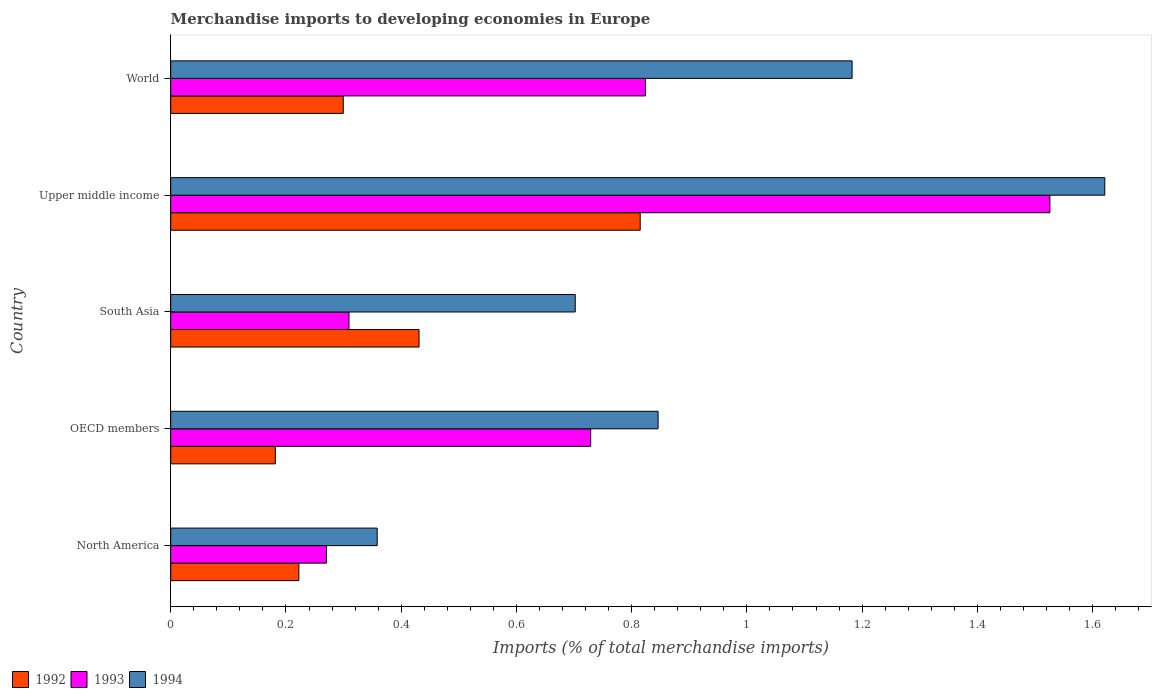How many different coloured bars are there?
Provide a short and direct response. 3. How many groups of bars are there?
Give a very brief answer. 5. Are the number of bars on each tick of the Y-axis equal?
Your answer should be compact. Yes. How many bars are there on the 5th tick from the top?
Give a very brief answer. 3. What is the label of the 1st group of bars from the top?
Offer a terse response. World. In how many cases, is the number of bars for a given country not equal to the number of legend labels?
Your answer should be compact. 0. What is the percentage total merchandise imports in 1994 in North America?
Keep it short and to the point. 0.36. Across all countries, what is the maximum percentage total merchandise imports in 1993?
Your response must be concise. 1.53. Across all countries, what is the minimum percentage total merchandise imports in 1992?
Keep it short and to the point. 0.18. In which country was the percentage total merchandise imports in 1993 maximum?
Provide a succinct answer. Upper middle income. In which country was the percentage total merchandise imports in 1994 minimum?
Provide a succinct answer. North America. What is the total percentage total merchandise imports in 1992 in the graph?
Your answer should be very brief. 1.95. What is the difference between the percentage total merchandise imports in 1994 in South Asia and that in Upper middle income?
Your answer should be compact. -0.92. What is the difference between the percentage total merchandise imports in 1994 in South Asia and the percentage total merchandise imports in 1993 in World?
Provide a short and direct response. -0.12. What is the average percentage total merchandise imports in 1992 per country?
Ensure brevity in your answer.  0.39. What is the difference between the percentage total merchandise imports in 1994 and percentage total merchandise imports in 1992 in Upper middle income?
Give a very brief answer. 0.81. What is the ratio of the percentage total merchandise imports in 1993 in OECD members to that in South Asia?
Offer a very short reply. 2.36. Is the percentage total merchandise imports in 1994 in North America less than that in World?
Offer a very short reply. Yes. What is the difference between the highest and the second highest percentage total merchandise imports in 1992?
Provide a short and direct response. 0.38. What is the difference between the highest and the lowest percentage total merchandise imports in 1993?
Your answer should be very brief. 1.26. In how many countries, is the percentage total merchandise imports in 1994 greater than the average percentage total merchandise imports in 1994 taken over all countries?
Your answer should be very brief. 2. Is the sum of the percentage total merchandise imports in 1993 in North America and OECD members greater than the maximum percentage total merchandise imports in 1994 across all countries?
Keep it short and to the point. No. What does the 1st bar from the top in South Asia represents?
Give a very brief answer. 1994. What does the 1st bar from the bottom in OECD members represents?
Provide a succinct answer. 1992. How many bars are there?
Provide a short and direct response. 15. How many countries are there in the graph?
Provide a succinct answer. 5. What is the difference between two consecutive major ticks on the X-axis?
Ensure brevity in your answer.  0.2. Does the graph contain any zero values?
Keep it short and to the point. No. Does the graph contain grids?
Your answer should be very brief. No. What is the title of the graph?
Provide a short and direct response. Merchandise imports to developing economies in Europe. Does "1968" appear as one of the legend labels in the graph?
Your answer should be very brief. No. What is the label or title of the X-axis?
Offer a very short reply. Imports (% of total merchandise imports). What is the label or title of the Y-axis?
Make the answer very short. Country. What is the Imports (% of total merchandise imports) in 1992 in North America?
Your response must be concise. 0.22. What is the Imports (% of total merchandise imports) in 1993 in North America?
Your response must be concise. 0.27. What is the Imports (% of total merchandise imports) in 1994 in North America?
Provide a short and direct response. 0.36. What is the Imports (% of total merchandise imports) in 1992 in OECD members?
Provide a succinct answer. 0.18. What is the Imports (% of total merchandise imports) in 1993 in OECD members?
Keep it short and to the point. 0.73. What is the Imports (% of total merchandise imports) of 1994 in OECD members?
Keep it short and to the point. 0.85. What is the Imports (% of total merchandise imports) in 1992 in South Asia?
Give a very brief answer. 0.43. What is the Imports (% of total merchandise imports) in 1993 in South Asia?
Make the answer very short. 0.31. What is the Imports (% of total merchandise imports) in 1994 in South Asia?
Keep it short and to the point. 0.7. What is the Imports (% of total merchandise imports) of 1992 in Upper middle income?
Your response must be concise. 0.81. What is the Imports (% of total merchandise imports) in 1993 in Upper middle income?
Your response must be concise. 1.53. What is the Imports (% of total merchandise imports) of 1994 in Upper middle income?
Make the answer very short. 1.62. What is the Imports (% of total merchandise imports) of 1992 in World?
Your response must be concise. 0.3. What is the Imports (% of total merchandise imports) in 1993 in World?
Your answer should be very brief. 0.82. What is the Imports (% of total merchandise imports) in 1994 in World?
Provide a succinct answer. 1.18. Across all countries, what is the maximum Imports (% of total merchandise imports) in 1992?
Make the answer very short. 0.81. Across all countries, what is the maximum Imports (% of total merchandise imports) in 1993?
Make the answer very short. 1.53. Across all countries, what is the maximum Imports (% of total merchandise imports) of 1994?
Your response must be concise. 1.62. Across all countries, what is the minimum Imports (% of total merchandise imports) of 1992?
Keep it short and to the point. 0.18. Across all countries, what is the minimum Imports (% of total merchandise imports) in 1993?
Your response must be concise. 0.27. Across all countries, what is the minimum Imports (% of total merchandise imports) in 1994?
Provide a succinct answer. 0.36. What is the total Imports (% of total merchandise imports) in 1992 in the graph?
Ensure brevity in your answer.  1.95. What is the total Imports (% of total merchandise imports) of 1993 in the graph?
Your answer should be compact. 3.66. What is the total Imports (% of total merchandise imports) in 1994 in the graph?
Your response must be concise. 4.71. What is the difference between the Imports (% of total merchandise imports) in 1992 in North America and that in OECD members?
Give a very brief answer. 0.04. What is the difference between the Imports (% of total merchandise imports) of 1993 in North America and that in OECD members?
Your answer should be compact. -0.46. What is the difference between the Imports (% of total merchandise imports) of 1994 in North America and that in OECD members?
Give a very brief answer. -0.49. What is the difference between the Imports (% of total merchandise imports) of 1992 in North America and that in South Asia?
Offer a very short reply. -0.21. What is the difference between the Imports (% of total merchandise imports) of 1993 in North America and that in South Asia?
Keep it short and to the point. -0.04. What is the difference between the Imports (% of total merchandise imports) in 1994 in North America and that in South Asia?
Provide a succinct answer. -0.34. What is the difference between the Imports (% of total merchandise imports) in 1992 in North America and that in Upper middle income?
Your answer should be compact. -0.59. What is the difference between the Imports (% of total merchandise imports) of 1993 in North America and that in Upper middle income?
Give a very brief answer. -1.26. What is the difference between the Imports (% of total merchandise imports) of 1994 in North America and that in Upper middle income?
Offer a terse response. -1.26. What is the difference between the Imports (% of total merchandise imports) of 1992 in North America and that in World?
Make the answer very short. -0.08. What is the difference between the Imports (% of total merchandise imports) of 1993 in North America and that in World?
Ensure brevity in your answer.  -0.55. What is the difference between the Imports (% of total merchandise imports) in 1994 in North America and that in World?
Offer a very short reply. -0.82. What is the difference between the Imports (% of total merchandise imports) in 1992 in OECD members and that in South Asia?
Ensure brevity in your answer.  -0.25. What is the difference between the Imports (% of total merchandise imports) of 1993 in OECD members and that in South Asia?
Offer a terse response. 0.42. What is the difference between the Imports (% of total merchandise imports) in 1994 in OECD members and that in South Asia?
Ensure brevity in your answer.  0.14. What is the difference between the Imports (% of total merchandise imports) in 1992 in OECD members and that in Upper middle income?
Ensure brevity in your answer.  -0.63. What is the difference between the Imports (% of total merchandise imports) of 1993 in OECD members and that in Upper middle income?
Offer a very short reply. -0.8. What is the difference between the Imports (% of total merchandise imports) of 1994 in OECD members and that in Upper middle income?
Offer a very short reply. -0.78. What is the difference between the Imports (% of total merchandise imports) in 1992 in OECD members and that in World?
Provide a short and direct response. -0.12. What is the difference between the Imports (% of total merchandise imports) of 1993 in OECD members and that in World?
Offer a terse response. -0.1. What is the difference between the Imports (% of total merchandise imports) in 1994 in OECD members and that in World?
Your answer should be compact. -0.34. What is the difference between the Imports (% of total merchandise imports) in 1992 in South Asia and that in Upper middle income?
Offer a terse response. -0.38. What is the difference between the Imports (% of total merchandise imports) in 1993 in South Asia and that in Upper middle income?
Make the answer very short. -1.22. What is the difference between the Imports (% of total merchandise imports) in 1994 in South Asia and that in Upper middle income?
Your answer should be very brief. -0.92. What is the difference between the Imports (% of total merchandise imports) of 1992 in South Asia and that in World?
Keep it short and to the point. 0.13. What is the difference between the Imports (% of total merchandise imports) in 1993 in South Asia and that in World?
Your answer should be compact. -0.51. What is the difference between the Imports (% of total merchandise imports) in 1994 in South Asia and that in World?
Offer a very short reply. -0.48. What is the difference between the Imports (% of total merchandise imports) in 1992 in Upper middle income and that in World?
Provide a short and direct response. 0.52. What is the difference between the Imports (% of total merchandise imports) in 1993 in Upper middle income and that in World?
Your answer should be compact. 0.7. What is the difference between the Imports (% of total merchandise imports) of 1994 in Upper middle income and that in World?
Your answer should be very brief. 0.44. What is the difference between the Imports (% of total merchandise imports) of 1992 in North America and the Imports (% of total merchandise imports) of 1993 in OECD members?
Your answer should be compact. -0.51. What is the difference between the Imports (% of total merchandise imports) in 1992 in North America and the Imports (% of total merchandise imports) in 1994 in OECD members?
Offer a terse response. -0.62. What is the difference between the Imports (% of total merchandise imports) of 1993 in North America and the Imports (% of total merchandise imports) of 1994 in OECD members?
Provide a short and direct response. -0.58. What is the difference between the Imports (% of total merchandise imports) of 1992 in North America and the Imports (% of total merchandise imports) of 1993 in South Asia?
Your answer should be very brief. -0.09. What is the difference between the Imports (% of total merchandise imports) of 1992 in North America and the Imports (% of total merchandise imports) of 1994 in South Asia?
Make the answer very short. -0.48. What is the difference between the Imports (% of total merchandise imports) in 1993 in North America and the Imports (% of total merchandise imports) in 1994 in South Asia?
Keep it short and to the point. -0.43. What is the difference between the Imports (% of total merchandise imports) of 1992 in North America and the Imports (% of total merchandise imports) of 1993 in Upper middle income?
Keep it short and to the point. -1.3. What is the difference between the Imports (% of total merchandise imports) in 1992 in North America and the Imports (% of total merchandise imports) in 1994 in Upper middle income?
Your answer should be very brief. -1.4. What is the difference between the Imports (% of total merchandise imports) of 1993 in North America and the Imports (% of total merchandise imports) of 1994 in Upper middle income?
Your answer should be very brief. -1.35. What is the difference between the Imports (% of total merchandise imports) in 1992 in North America and the Imports (% of total merchandise imports) in 1993 in World?
Keep it short and to the point. -0.6. What is the difference between the Imports (% of total merchandise imports) of 1992 in North America and the Imports (% of total merchandise imports) of 1994 in World?
Keep it short and to the point. -0.96. What is the difference between the Imports (% of total merchandise imports) in 1993 in North America and the Imports (% of total merchandise imports) in 1994 in World?
Keep it short and to the point. -0.91. What is the difference between the Imports (% of total merchandise imports) in 1992 in OECD members and the Imports (% of total merchandise imports) in 1993 in South Asia?
Keep it short and to the point. -0.13. What is the difference between the Imports (% of total merchandise imports) of 1992 in OECD members and the Imports (% of total merchandise imports) of 1994 in South Asia?
Ensure brevity in your answer.  -0.52. What is the difference between the Imports (% of total merchandise imports) in 1993 in OECD members and the Imports (% of total merchandise imports) in 1994 in South Asia?
Your answer should be very brief. 0.03. What is the difference between the Imports (% of total merchandise imports) in 1992 in OECD members and the Imports (% of total merchandise imports) in 1993 in Upper middle income?
Offer a very short reply. -1.34. What is the difference between the Imports (% of total merchandise imports) in 1992 in OECD members and the Imports (% of total merchandise imports) in 1994 in Upper middle income?
Make the answer very short. -1.44. What is the difference between the Imports (% of total merchandise imports) of 1993 in OECD members and the Imports (% of total merchandise imports) of 1994 in Upper middle income?
Offer a very short reply. -0.89. What is the difference between the Imports (% of total merchandise imports) in 1992 in OECD members and the Imports (% of total merchandise imports) in 1993 in World?
Give a very brief answer. -0.64. What is the difference between the Imports (% of total merchandise imports) in 1992 in OECD members and the Imports (% of total merchandise imports) in 1994 in World?
Your answer should be compact. -1. What is the difference between the Imports (% of total merchandise imports) of 1993 in OECD members and the Imports (% of total merchandise imports) of 1994 in World?
Offer a terse response. -0.45. What is the difference between the Imports (% of total merchandise imports) of 1992 in South Asia and the Imports (% of total merchandise imports) of 1993 in Upper middle income?
Ensure brevity in your answer.  -1.09. What is the difference between the Imports (% of total merchandise imports) of 1992 in South Asia and the Imports (% of total merchandise imports) of 1994 in Upper middle income?
Provide a succinct answer. -1.19. What is the difference between the Imports (% of total merchandise imports) in 1993 in South Asia and the Imports (% of total merchandise imports) in 1994 in Upper middle income?
Your response must be concise. -1.31. What is the difference between the Imports (% of total merchandise imports) in 1992 in South Asia and the Imports (% of total merchandise imports) in 1993 in World?
Make the answer very short. -0.39. What is the difference between the Imports (% of total merchandise imports) of 1992 in South Asia and the Imports (% of total merchandise imports) of 1994 in World?
Ensure brevity in your answer.  -0.75. What is the difference between the Imports (% of total merchandise imports) in 1993 in South Asia and the Imports (% of total merchandise imports) in 1994 in World?
Offer a very short reply. -0.87. What is the difference between the Imports (% of total merchandise imports) of 1992 in Upper middle income and the Imports (% of total merchandise imports) of 1993 in World?
Give a very brief answer. -0.01. What is the difference between the Imports (% of total merchandise imports) of 1992 in Upper middle income and the Imports (% of total merchandise imports) of 1994 in World?
Offer a terse response. -0.37. What is the difference between the Imports (% of total merchandise imports) of 1993 in Upper middle income and the Imports (% of total merchandise imports) of 1994 in World?
Ensure brevity in your answer.  0.34. What is the average Imports (% of total merchandise imports) of 1992 per country?
Give a very brief answer. 0.39. What is the average Imports (% of total merchandise imports) of 1993 per country?
Offer a very short reply. 0.73. What is the average Imports (% of total merchandise imports) in 1994 per country?
Keep it short and to the point. 0.94. What is the difference between the Imports (% of total merchandise imports) of 1992 and Imports (% of total merchandise imports) of 1993 in North America?
Your answer should be very brief. -0.05. What is the difference between the Imports (% of total merchandise imports) in 1992 and Imports (% of total merchandise imports) in 1994 in North America?
Your answer should be very brief. -0.14. What is the difference between the Imports (% of total merchandise imports) in 1993 and Imports (% of total merchandise imports) in 1994 in North America?
Offer a very short reply. -0.09. What is the difference between the Imports (% of total merchandise imports) of 1992 and Imports (% of total merchandise imports) of 1993 in OECD members?
Offer a very short reply. -0.55. What is the difference between the Imports (% of total merchandise imports) in 1992 and Imports (% of total merchandise imports) in 1994 in OECD members?
Offer a terse response. -0.66. What is the difference between the Imports (% of total merchandise imports) of 1993 and Imports (% of total merchandise imports) of 1994 in OECD members?
Offer a very short reply. -0.12. What is the difference between the Imports (% of total merchandise imports) in 1992 and Imports (% of total merchandise imports) in 1993 in South Asia?
Make the answer very short. 0.12. What is the difference between the Imports (% of total merchandise imports) of 1992 and Imports (% of total merchandise imports) of 1994 in South Asia?
Give a very brief answer. -0.27. What is the difference between the Imports (% of total merchandise imports) of 1993 and Imports (% of total merchandise imports) of 1994 in South Asia?
Provide a short and direct response. -0.39. What is the difference between the Imports (% of total merchandise imports) in 1992 and Imports (% of total merchandise imports) in 1993 in Upper middle income?
Your response must be concise. -0.71. What is the difference between the Imports (% of total merchandise imports) of 1992 and Imports (% of total merchandise imports) of 1994 in Upper middle income?
Give a very brief answer. -0.81. What is the difference between the Imports (% of total merchandise imports) of 1993 and Imports (% of total merchandise imports) of 1994 in Upper middle income?
Give a very brief answer. -0.1. What is the difference between the Imports (% of total merchandise imports) of 1992 and Imports (% of total merchandise imports) of 1993 in World?
Offer a terse response. -0.52. What is the difference between the Imports (% of total merchandise imports) in 1992 and Imports (% of total merchandise imports) in 1994 in World?
Your response must be concise. -0.88. What is the difference between the Imports (% of total merchandise imports) in 1993 and Imports (% of total merchandise imports) in 1994 in World?
Offer a very short reply. -0.36. What is the ratio of the Imports (% of total merchandise imports) of 1992 in North America to that in OECD members?
Offer a very short reply. 1.23. What is the ratio of the Imports (% of total merchandise imports) of 1993 in North America to that in OECD members?
Keep it short and to the point. 0.37. What is the ratio of the Imports (% of total merchandise imports) of 1994 in North America to that in OECD members?
Ensure brevity in your answer.  0.42. What is the ratio of the Imports (% of total merchandise imports) in 1992 in North America to that in South Asia?
Provide a short and direct response. 0.52. What is the ratio of the Imports (% of total merchandise imports) in 1993 in North America to that in South Asia?
Make the answer very short. 0.87. What is the ratio of the Imports (% of total merchandise imports) of 1994 in North America to that in South Asia?
Provide a short and direct response. 0.51. What is the ratio of the Imports (% of total merchandise imports) in 1992 in North America to that in Upper middle income?
Give a very brief answer. 0.27. What is the ratio of the Imports (% of total merchandise imports) in 1993 in North America to that in Upper middle income?
Your answer should be very brief. 0.18. What is the ratio of the Imports (% of total merchandise imports) in 1994 in North America to that in Upper middle income?
Provide a short and direct response. 0.22. What is the ratio of the Imports (% of total merchandise imports) of 1992 in North America to that in World?
Offer a very short reply. 0.74. What is the ratio of the Imports (% of total merchandise imports) of 1993 in North America to that in World?
Make the answer very short. 0.33. What is the ratio of the Imports (% of total merchandise imports) in 1994 in North America to that in World?
Offer a very short reply. 0.3. What is the ratio of the Imports (% of total merchandise imports) of 1992 in OECD members to that in South Asia?
Ensure brevity in your answer.  0.42. What is the ratio of the Imports (% of total merchandise imports) of 1993 in OECD members to that in South Asia?
Your response must be concise. 2.36. What is the ratio of the Imports (% of total merchandise imports) in 1994 in OECD members to that in South Asia?
Your answer should be very brief. 1.2. What is the ratio of the Imports (% of total merchandise imports) of 1992 in OECD members to that in Upper middle income?
Keep it short and to the point. 0.22. What is the ratio of the Imports (% of total merchandise imports) in 1993 in OECD members to that in Upper middle income?
Keep it short and to the point. 0.48. What is the ratio of the Imports (% of total merchandise imports) in 1994 in OECD members to that in Upper middle income?
Offer a terse response. 0.52. What is the ratio of the Imports (% of total merchandise imports) in 1992 in OECD members to that in World?
Make the answer very short. 0.61. What is the ratio of the Imports (% of total merchandise imports) of 1993 in OECD members to that in World?
Ensure brevity in your answer.  0.88. What is the ratio of the Imports (% of total merchandise imports) in 1994 in OECD members to that in World?
Offer a terse response. 0.72. What is the ratio of the Imports (% of total merchandise imports) of 1992 in South Asia to that in Upper middle income?
Provide a short and direct response. 0.53. What is the ratio of the Imports (% of total merchandise imports) of 1993 in South Asia to that in Upper middle income?
Ensure brevity in your answer.  0.2. What is the ratio of the Imports (% of total merchandise imports) in 1994 in South Asia to that in Upper middle income?
Give a very brief answer. 0.43. What is the ratio of the Imports (% of total merchandise imports) in 1992 in South Asia to that in World?
Provide a succinct answer. 1.44. What is the ratio of the Imports (% of total merchandise imports) of 1993 in South Asia to that in World?
Keep it short and to the point. 0.38. What is the ratio of the Imports (% of total merchandise imports) in 1994 in South Asia to that in World?
Ensure brevity in your answer.  0.59. What is the ratio of the Imports (% of total merchandise imports) of 1992 in Upper middle income to that in World?
Ensure brevity in your answer.  2.72. What is the ratio of the Imports (% of total merchandise imports) of 1993 in Upper middle income to that in World?
Your answer should be compact. 1.85. What is the ratio of the Imports (% of total merchandise imports) of 1994 in Upper middle income to that in World?
Keep it short and to the point. 1.37. What is the difference between the highest and the second highest Imports (% of total merchandise imports) of 1992?
Provide a short and direct response. 0.38. What is the difference between the highest and the second highest Imports (% of total merchandise imports) in 1993?
Offer a very short reply. 0.7. What is the difference between the highest and the second highest Imports (% of total merchandise imports) in 1994?
Your response must be concise. 0.44. What is the difference between the highest and the lowest Imports (% of total merchandise imports) in 1992?
Give a very brief answer. 0.63. What is the difference between the highest and the lowest Imports (% of total merchandise imports) of 1993?
Your response must be concise. 1.26. What is the difference between the highest and the lowest Imports (% of total merchandise imports) of 1994?
Your response must be concise. 1.26. 